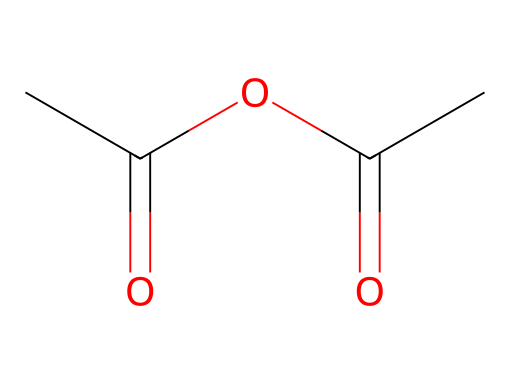What is the molecular formula of acetic anhydride? The SMILES representation indicates that the compound consists of four carbon atoms, six hydrogen atoms, and two oxygen atoms. Therefore, the molecular formula can be derived directly from that count.
Answer: C4H6O2 How many carbon atoms are present in acetic anhydride? By analyzing the SMILES string, we can count the number of carbon atoms present. Each 'C' represents one carbon atom, and there are four 'C' characters in the SMILES.
Answer: 4 What functional groups are present in acetic anhydride? The structure includes two acyl groups, which are recognized in the context of acid anhydrides. Specifically, acetic anhydride features carbonyl groups (C=O) attached to one oxygen.
Answer: acyl groups Does acetic anhydride have a higher or lower boiling point than acetic acid? Considering the structure of acetic anhydride, it is less polar because it lacks hydrogen bonding typically present in acetic acid, resulting in a lower boiling point.
Answer: lower What type of chemical reaction is acetic anhydride primarily involved in? Acetic anhydride typically acts as an acylating agent, meaning it plays a crucial role in acylation reactions, particularly in introducing acetyl groups into other compounds.
Answer: acylation What is the hybridization of the carbon atoms in acetic anhydride? By examining the carbon atoms in the structure, the hybridization can be determined based on their bonding. The carbon atoms involved in double bonds (carbonyls) exhibit sp2 hybridization, while those connected to two single bonds are sp3.
Answer: sp2 and sp3 